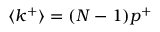<formula> <loc_0><loc_0><loc_500><loc_500>\langle k ^ { + } \rangle = ( N - 1 ) p ^ { + }</formula> 